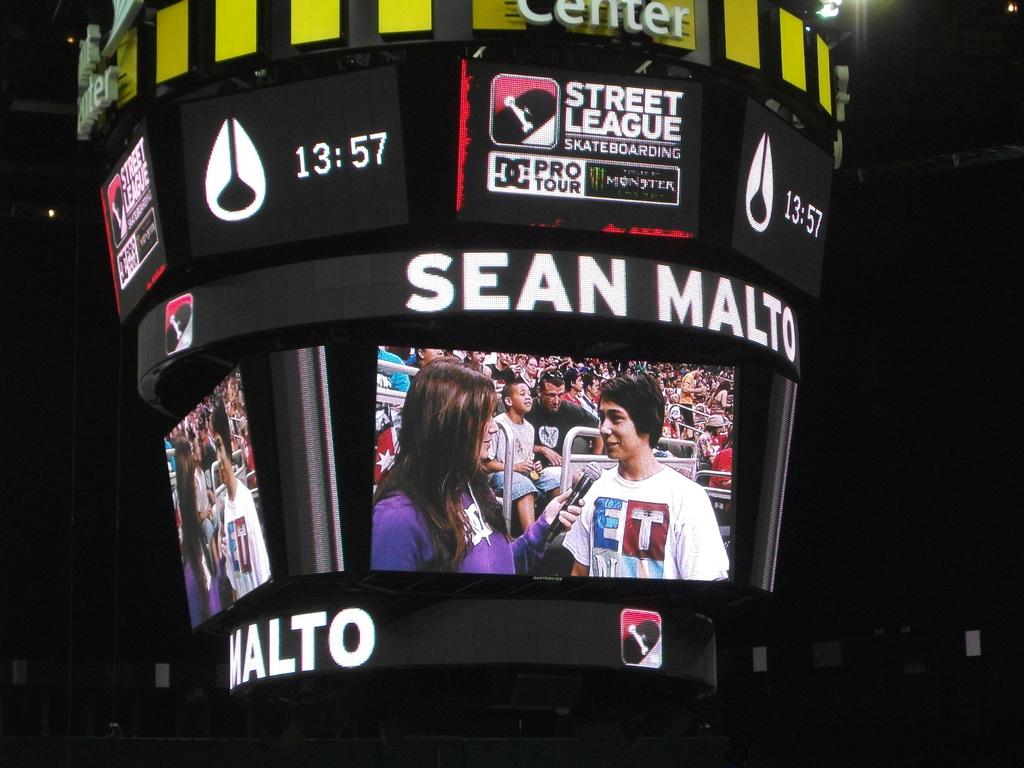How much tie is left on the clock?
Give a very brief answer. 13:57. What league is this?
Offer a terse response. Street. 